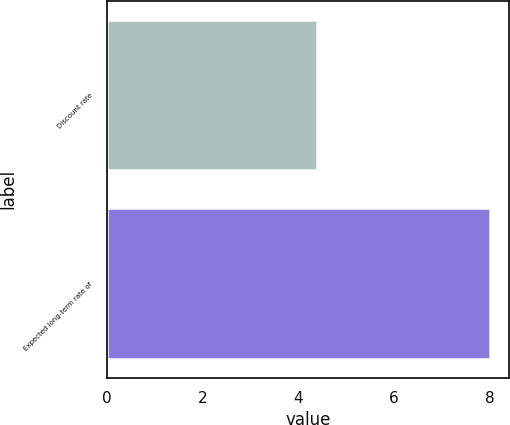Convert chart. <chart><loc_0><loc_0><loc_500><loc_500><bar_chart><fcel>Discount rate<fcel>Expected long-term rate of<nl><fcel>4.38<fcel>8<nl></chart> 